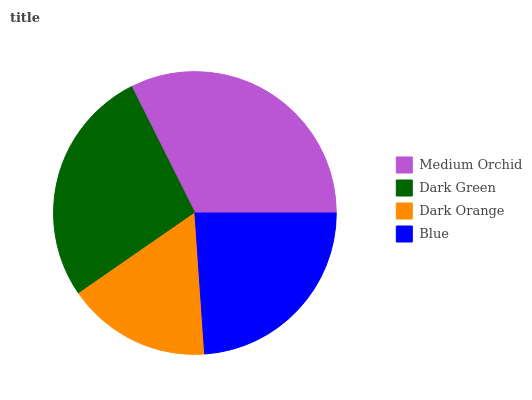Is Dark Orange the minimum?
Answer yes or no. Yes. Is Medium Orchid the maximum?
Answer yes or no. Yes. Is Dark Green the minimum?
Answer yes or no. No. Is Dark Green the maximum?
Answer yes or no. No. Is Medium Orchid greater than Dark Green?
Answer yes or no. Yes. Is Dark Green less than Medium Orchid?
Answer yes or no. Yes. Is Dark Green greater than Medium Orchid?
Answer yes or no. No. Is Medium Orchid less than Dark Green?
Answer yes or no. No. Is Dark Green the high median?
Answer yes or no. Yes. Is Blue the low median?
Answer yes or no. Yes. Is Medium Orchid the high median?
Answer yes or no. No. Is Dark Orange the low median?
Answer yes or no. No. 